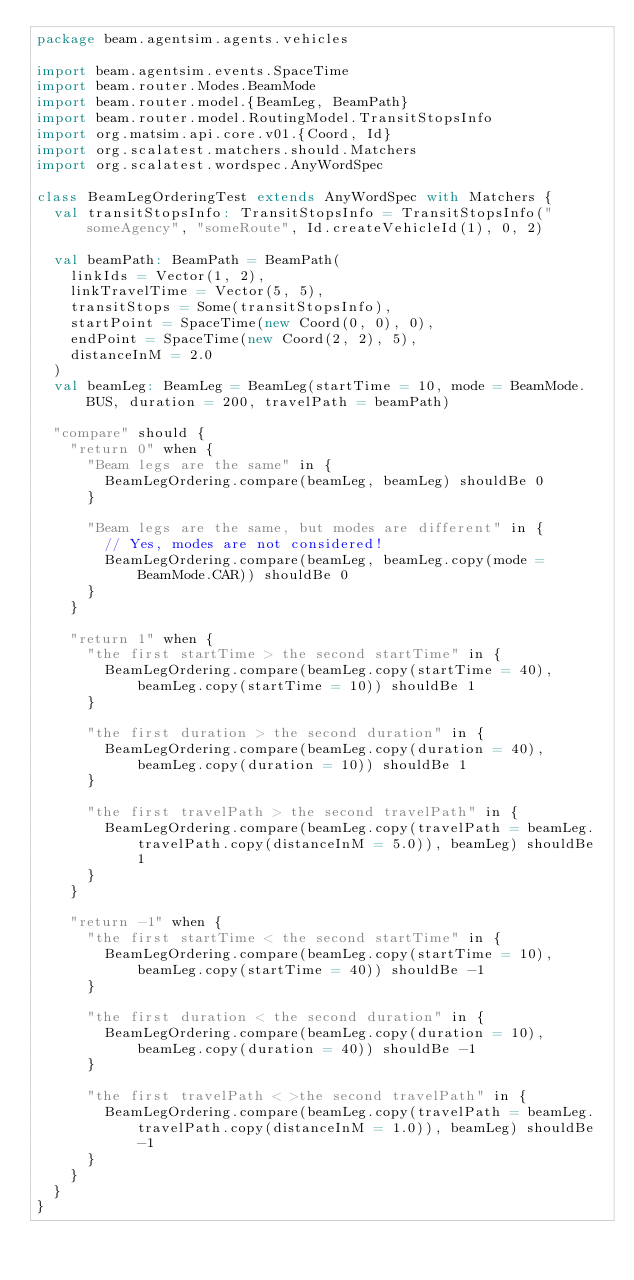<code> <loc_0><loc_0><loc_500><loc_500><_Scala_>package beam.agentsim.agents.vehicles

import beam.agentsim.events.SpaceTime
import beam.router.Modes.BeamMode
import beam.router.model.{BeamLeg, BeamPath}
import beam.router.model.RoutingModel.TransitStopsInfo
import org.matsim.api.core.v01.{Coord, Id}
import org.scalatest.matchers.should.Matchers
import org.scalatest.wordspec.AnyWordSpec

class BeamLegOrderingTest extends AnyWordSpec with Matchers {
  val transitStopsInfo: TransitStopsInfo = TransitStopsInfo("someAgency", "someRoute", Id.createVehicleId(1), 0, 2)

  val beamPath: BeamPath = BeamPath(
    linkIds = Vector(1, 2),
    linkTravelTime = Vector(5, 5),
    transitStops = Some(transitStopsInfo),
    startPoint = SpaceTime(new Coord(0, 0), 0),
    endPoint = SpaceTime(new Coord(2, 2), 5),
    distanceInM = 2.0
  )
  val beamLeg: BeamLeg = BeamLeg(startTime = 10, mode = BeamMode.BUS, duration = 200, travelPath = beamPath)

  "compare" should {
    "return 0" when {
      "Beam legs are the same" in {
        BeamLegOrdering.compare(beamLeg, beamLeg) shouldBe 0
      }

      "Beam legs are the same, but modes are different" in {
        // Yes, modes are not considered!
        BeamLegOrdering.compare(beamLeg, beamLeg.copy(mode = BeamMode.CAR)) shouldBe 0
      }
    }

    "return 1" when {
      "the first startTime > the second startTime" in {
        BeamLegOrdering.compare(beamLeg.copy(startTime = 40), beamLeg.copy(startTime = 10)) shouldBe 1
      }

      "the first duration > the second duration" in {
        BeamLegOrdering.compare(beamLeg.copy(duration = 40), beamLeg.copy(duration = 10)) shouldBe 1
      }

      "the first travelPath > the second travelPath" in {
        BeamLegOrdering.compare(beamLeg.copy(travelPath = beamLeg.travelPath.copy(distanceInM = 5.0)), beamLeg) shouldBe 1
      }
    }

    "return -1" when {
      "the first startTime < the second startTime" in {
        BeamLegOrdering.compare(beamLeg.copy(startTime = 10), beamLeg.copy(startTime = 40)) shouldBe -1
      }

      "the first duration < the second duration" in {
        BeamLegOrdering.compare(beamLeg.copy(duration = 10), beamLeg.copy(duration = 40)) shouldBe -1
      }

      "the first travelPath < >the second travelPath" in {
        BeamLegOrdering.compare(beamLeg.copy(travelPath = beamLeg.travelPath.copy(distanceInM = 1.0)), beamLeg) shouldBe -1
      }
    }
  }
}
</code> 